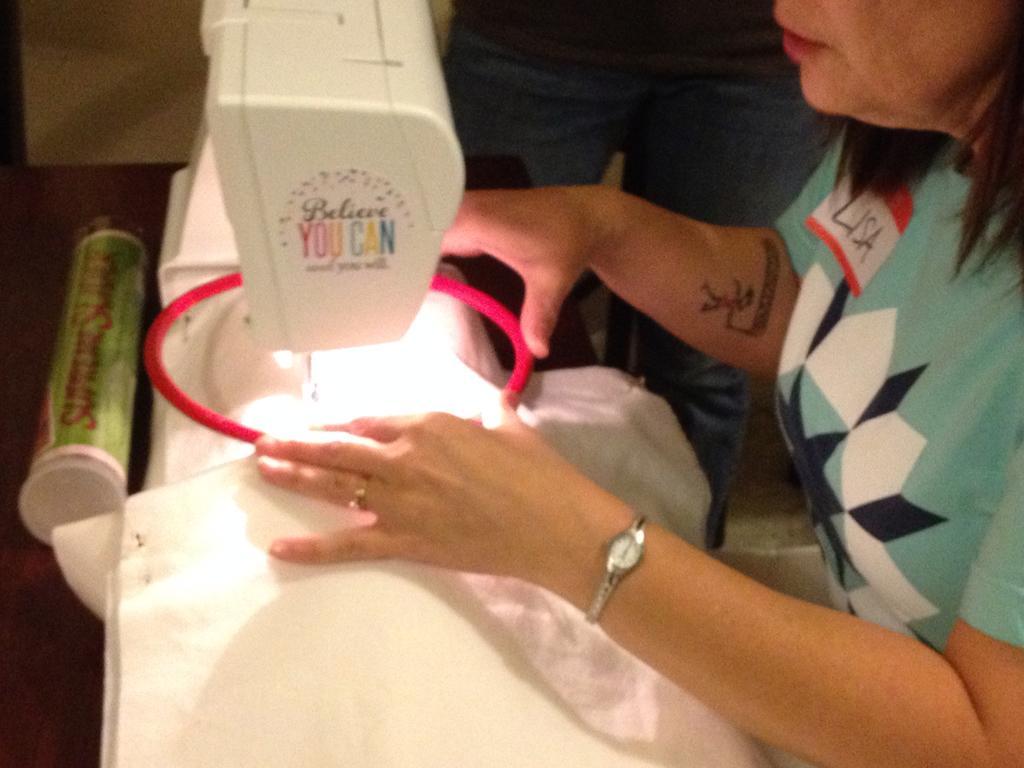In one or two sentences, can you explain what this image depicts? In the picture we can see a woman stitching the cloth under the machine and beside her we can see a person is standing. 